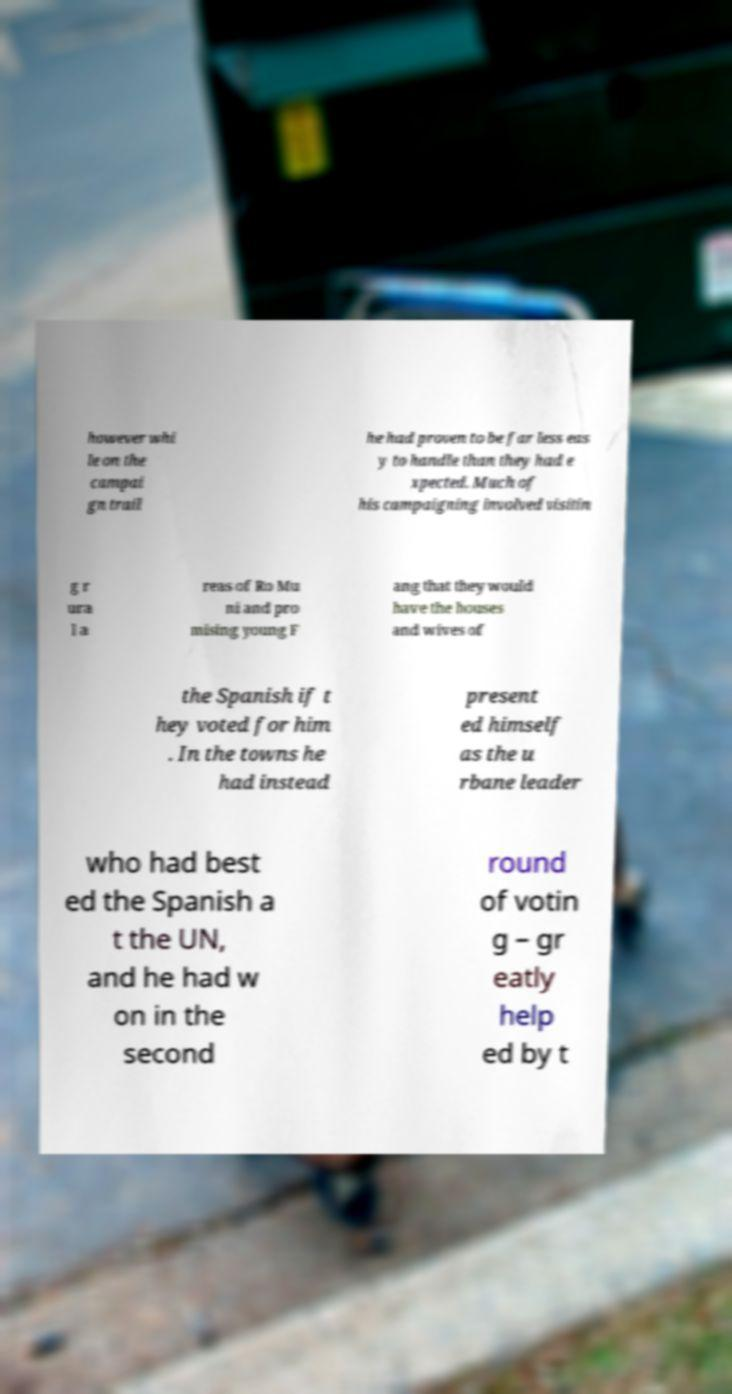Could you extract and type out the text from this image? however whi le on the campai gn trail he had proven to be far less eas y to handle than they had e xpected. Much of his campaigning involved visitin g r ura l a reas of Ro Mu ni and pro mising young F ang that they would have the houses and wives of the Spanish if t hey voted for him . In the towns he had instead present ed himself as the u rbane leader who had best ed the Spanish a t the UN, and he had w on in the second round of votin g – gr eatly help ed by t 